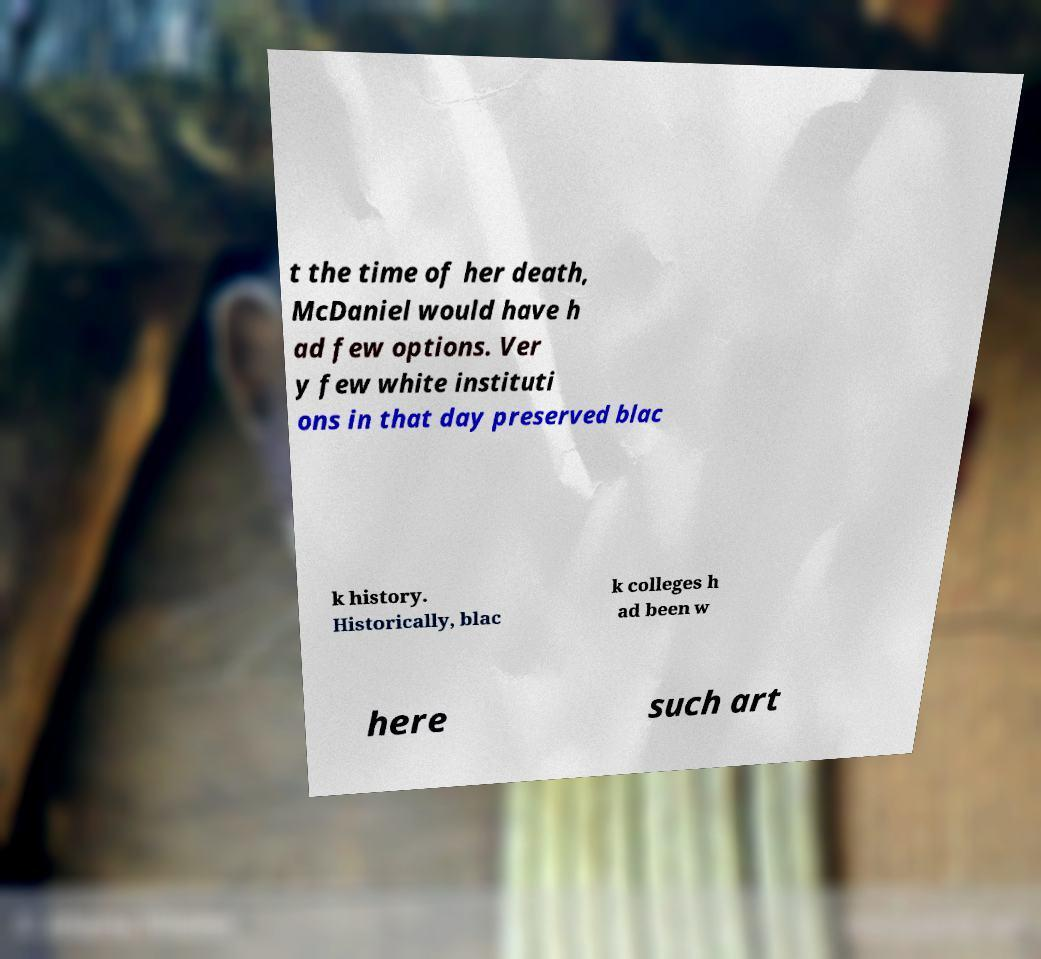Can you read and provide the text displayed in the image?This photo seems to have some interesting text. Can you extract and type it out for me? t the time of her death, McDaniel would have h ad few options. Ver y few white instituti ons in that day preserved blac k history. Historically, blac k colleges h ad been w here such art 